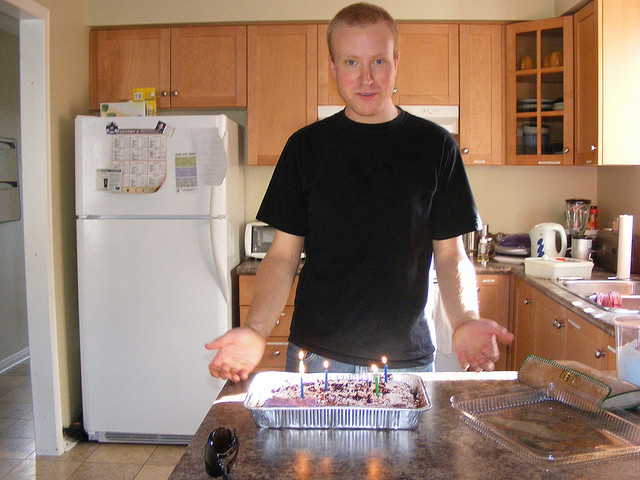<image>What brand is the man's shirt? I don't know what brand the man's shirt is. It could be 'hanes', 'nike', or 'lee'. What brand is the man's shirt? It is not clear what brand is the man's shirt. It can be Hanes, Nike or Lee. 